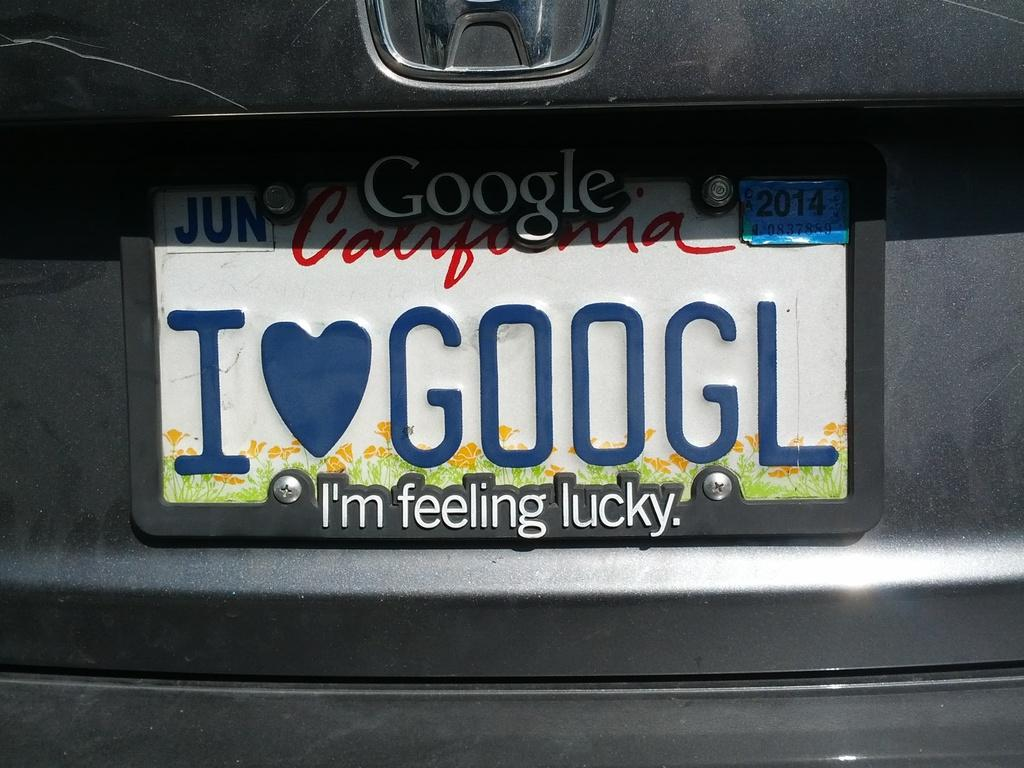<image>
Share a concise interpretation of the image provided. an I love Google license plate that is on a car 